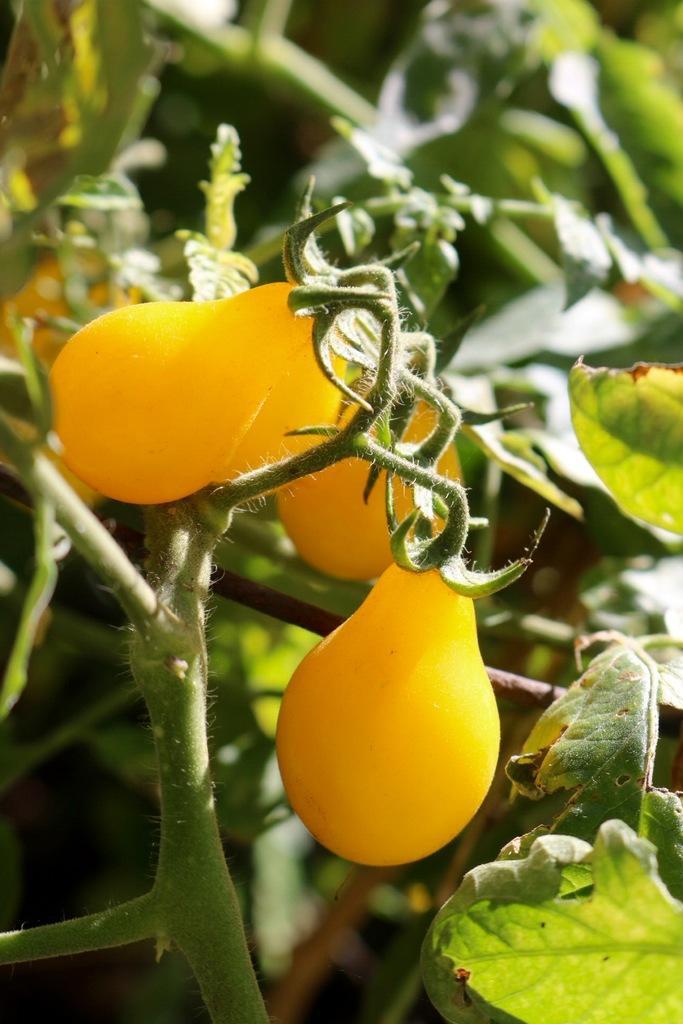In one or two sentences, can you explain what this image depicts? In this image there are some plants as we can see at bottom of this image and top of this image and there are some leaves to this plants and there are yellow colored fruits at middle of this image. 